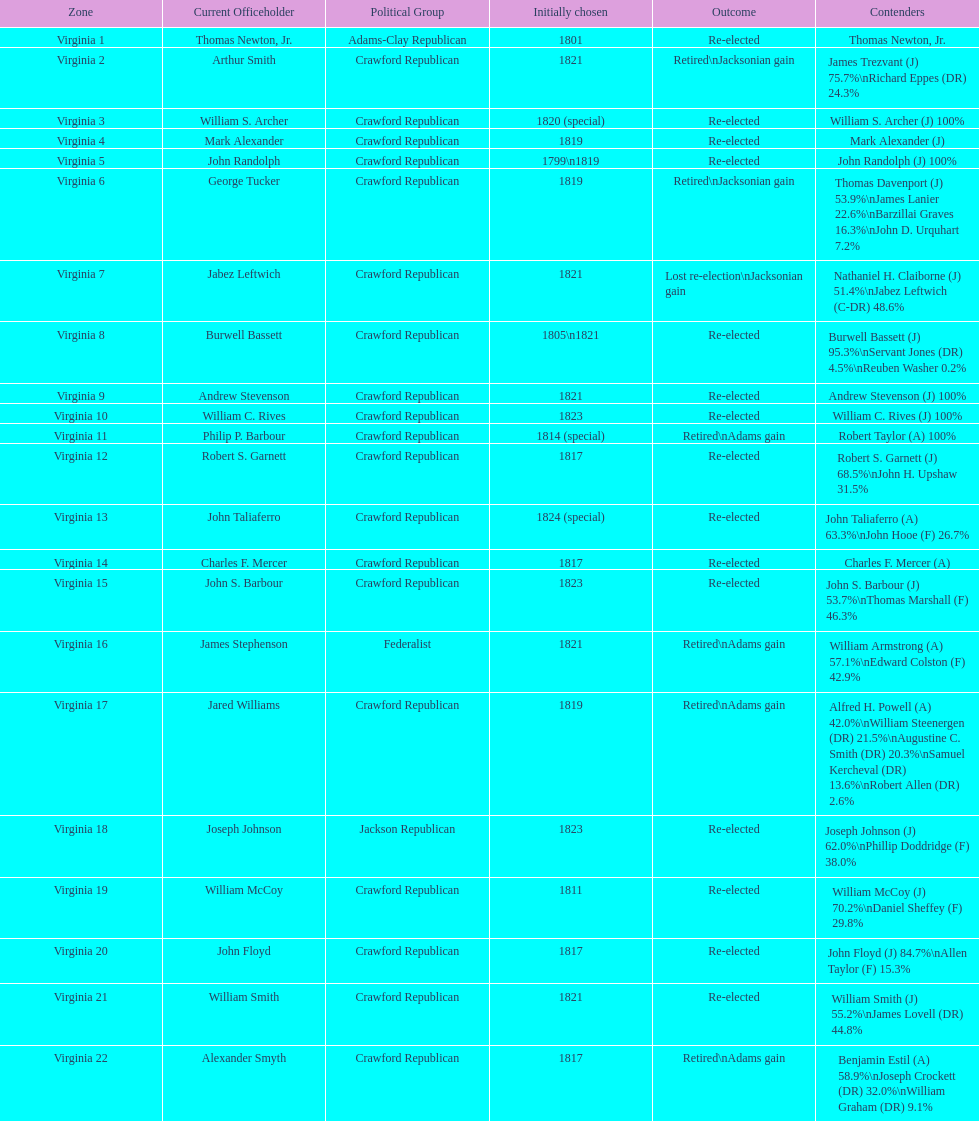Who was the next incumbent after john randolph? George Tucker. 